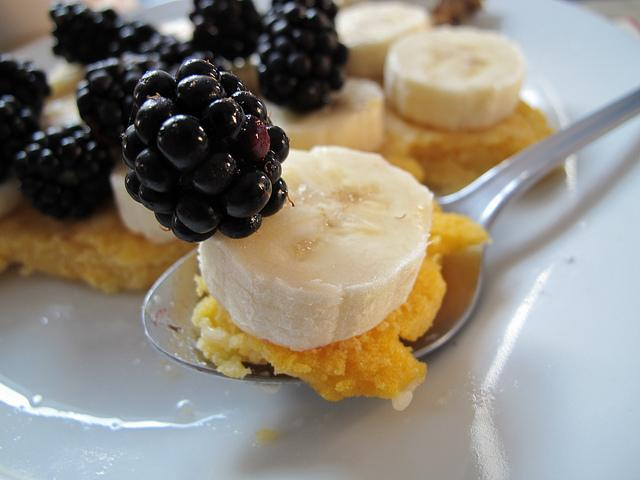What type of fruit is at the very top of the scoop with the banana and oat?

Choices:
A) cantaloupe
B) raspberry
C) blackberry
D) strawberry blackberry 